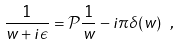<formula> <loc_0><loc_0><loc_500><loc_500>\frac { 1 } { w + i \epsilon } = { \mathcal { P } } \frac { 1 } { w } - i \pi \delta ( w ) \ ,</formula> 